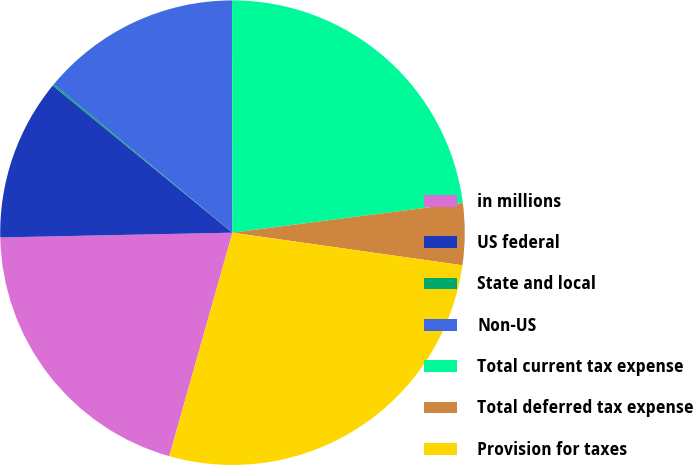<chart> <loc_0><loc_0><loc_500><loc_500><pie_chart><fcel>in millions<fcel>US federal<fcel>State and local<fcel>Non-US<fcel>Total current tax expense<fcel>Total deferred tax expense<fcel>Provision for taxes<nl><fcel>20.29%<fcel>11.24%<fcel>0.12%<fcel>13.94%<fcel>22.99%<fcel>4.28%<fcel>27.14%<nl></chart> 